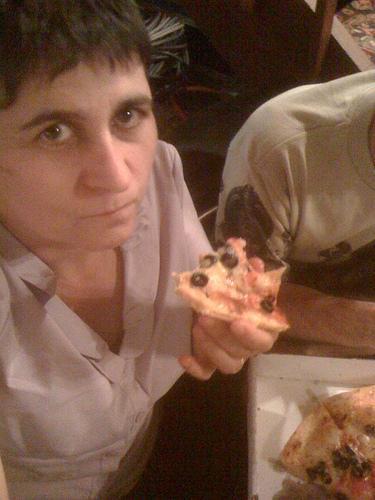How many people are in the photo?
Give a very brief answer. 2. How many dining tables can you see?
Give a very brief answer. 2. How many pizzas are in the picture?
Give a very brief answer. 2. How many giraffes are reaching for the branch?
Give a very brief answer. 0. 